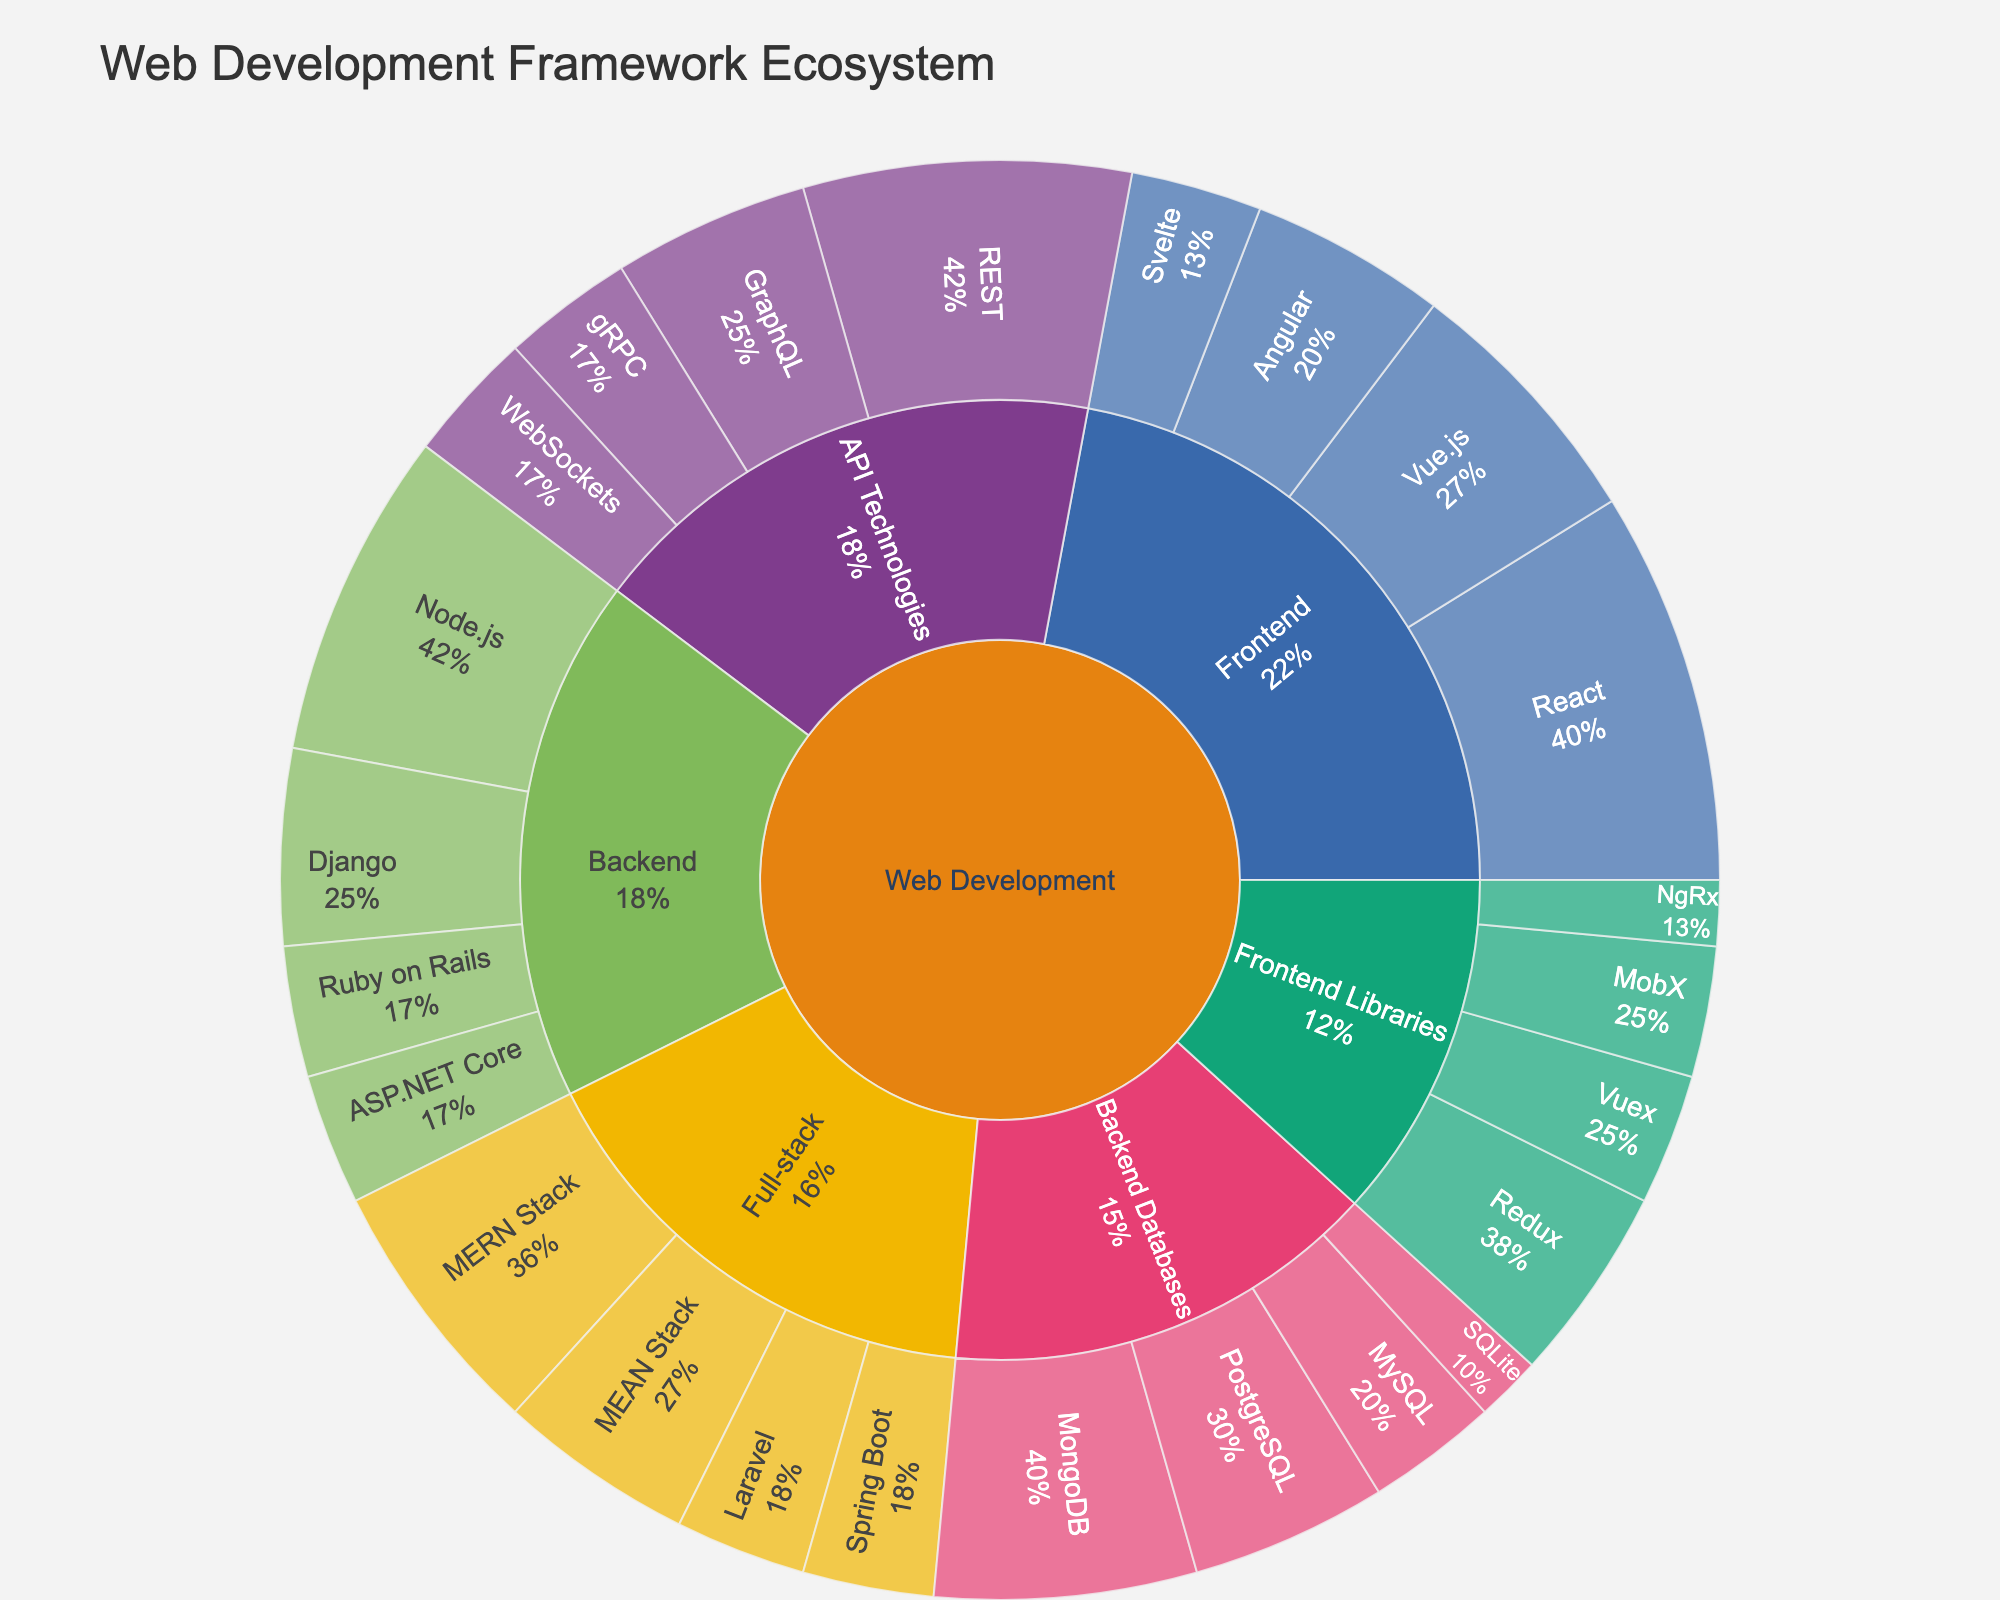Which technology in the Frontend subcategory has the highest popularity? The Frontend subcategory includes React, Vue.js, Angular, and Svelte. Among them, React has the highest popularity with a value of 30.
Answer: React What is the total popularity of technologies in the Backend subcategory? The Backend subcategory includes Node.js, Django, Ruby on Rails, and ASP.NET Core. Summing up their popularity values: 25 (Node.js) + 15 (Django) + 10 (Ruby on Rails) + 10 (ASP.NET Core) equals 60.
Answer: 60 Compare the popularity of the MERN Stack and MEAN Stack in the Full-stack subcategory. Which one is more popular? In the Full-stack subcategory, the MERN Stack has a popularity of 20, while the MEAN Stack has a popularity of 15. Therefore, the MERN Stack is more popular.
Answer: MERN Stack What percentage of the popularity in the Backend subcategory does Node.js contribute? Node.js has a popularity of 25, and the total popularity of the Backend subcategory is 60. The percentage is (25 / 60) * 100 = 41.7%.
Answer: 41.7% What is the combined popularity of all Full-stack technologies? The Full-stack subcategory includes MERN Stack (20), MEAN Stack (15), Laravel (10), and Spring Boot (10). The total is 20 + 15 + 10 + 10 = 55.
Answer: 55 What is the least popular technology in the Frontend Libraries subcategory? The Frontend Libraries subcategory includes Redux, MobX, Vuex, and NgRx. Among them, NgRx has the lowest popularity with a value of 5.
Answer: NgRx What is the combined popularity of REST and GraphQL in the API Technologies subcategory? REST has a popularity of 25, and GraphQL has a popularity of 15. The combined popularity is 25 + 15 = 40.
Answer: 40 Which Backend Database technology is more popular: PostgreSQL or MySQL? PostgreSQL has a popularity of 15, and MySQL has a popularity of 10. Therefore, PostgreSQL is more popular.
Answer: PostgreSQL How does the popularity of Vue.js in the Frontend subcategory compare to Django in the Backend subcategory? Vue.js has a popularity of 20, and Django has a popularity of 15. Vue.js is more popular than Django.
Answer: Vue.js What is the percentage of technologies in the Backend Databases subcategory compared to the total Web Development popularity? Backend Databases have the following popularities: MongoDB (20), PostgreSQL (15), MySQL (10), and SQLite (5). The total for this subcategory is 50. The total popularity for all categories can be calculated by adding all values in the given data. This would be 300. The percentage is (50 / 300) * 100 = 16.7%.
Answer: 16.7% 